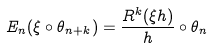Convert formula to latex. <formula><loc_0><loc_0><loc_500><loc_500>E _ { n } ( \xi \circ \theta _ { n + k } ) = \frac { R ^ { k } ( \xi h ) } { h } \circ \theta _ { n }</formula> 